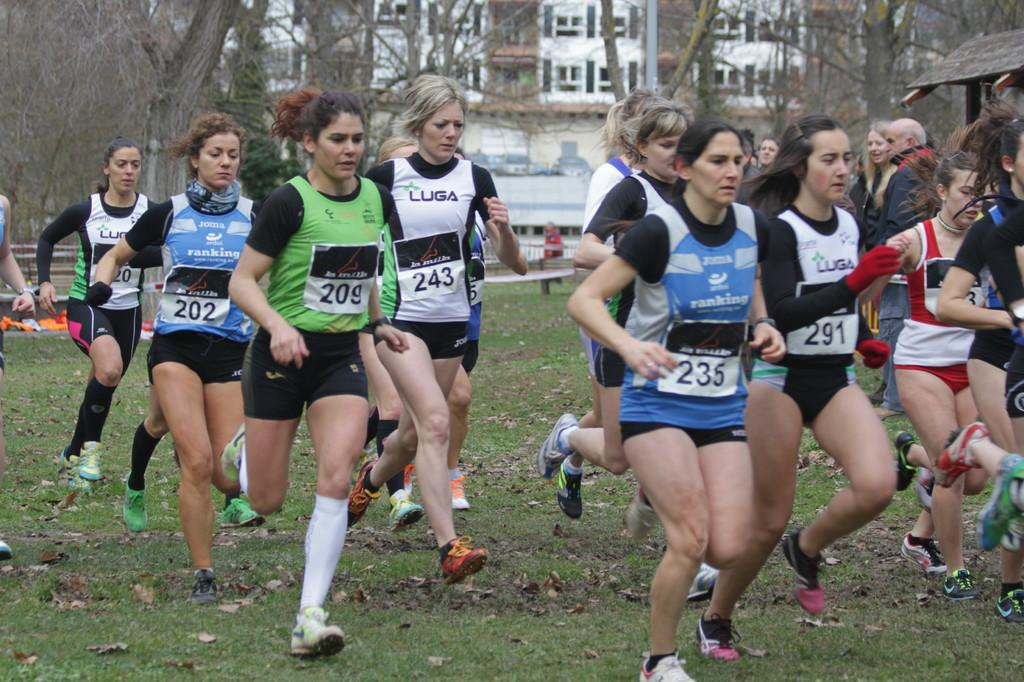<image>
Provide a brief description of the given image. A group of women running, the number 243 is on one of their shirts. 